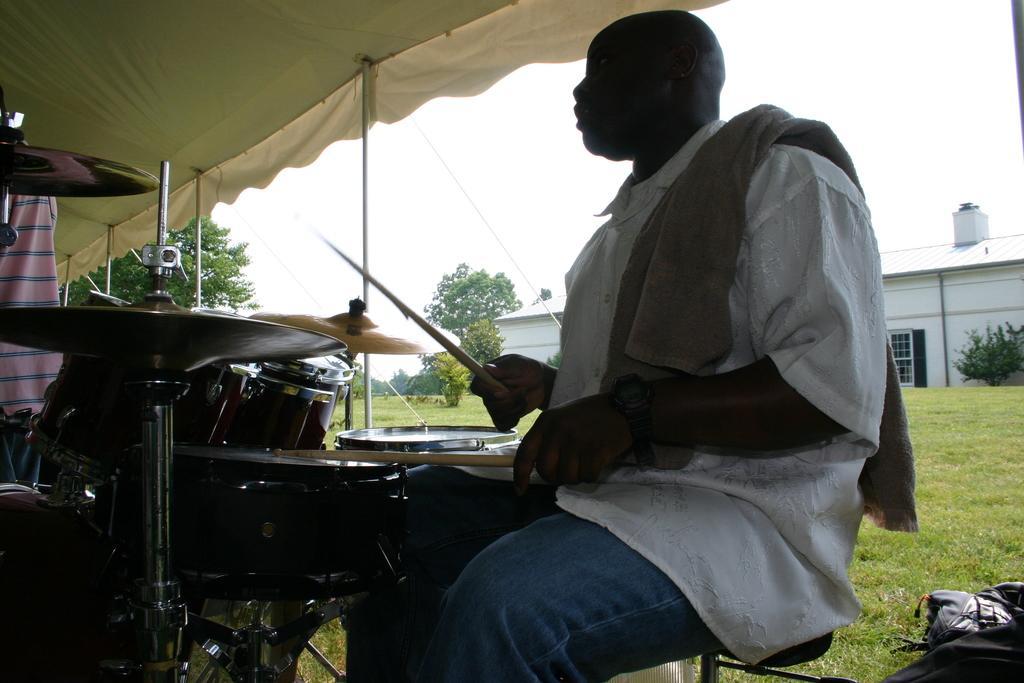Could you give a brief overview of what you see in this image? There is a man who is playing drums. This is grass and there is a house. These are some plants and there are trees. And this is sky. 